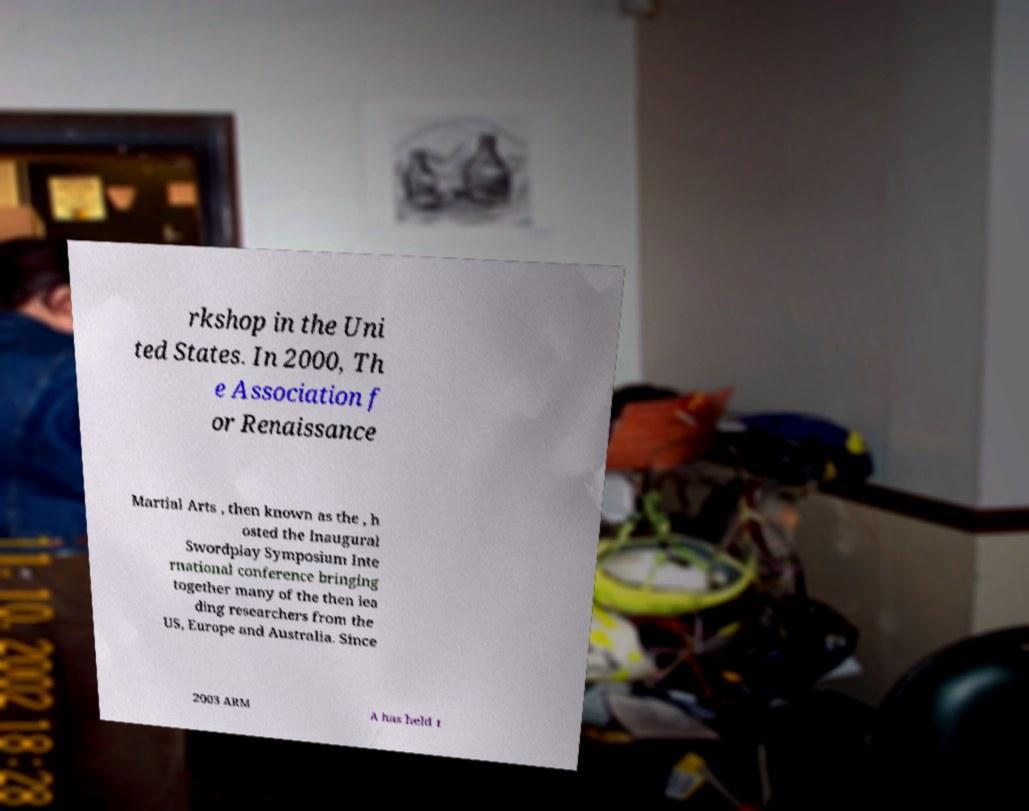Could you assist in decoding the text presented in this image and type it out clearly? rkshop in the Uni ted States. In 2000, Th e Association f or Renaissance Martial Arts , then known as the , h osted the Inaugural Swordplay Symposium Inte rnational conference bringing together many of the then lea ding researchers from the US, Europe and Australia. Since 2003 ARM A has held t 